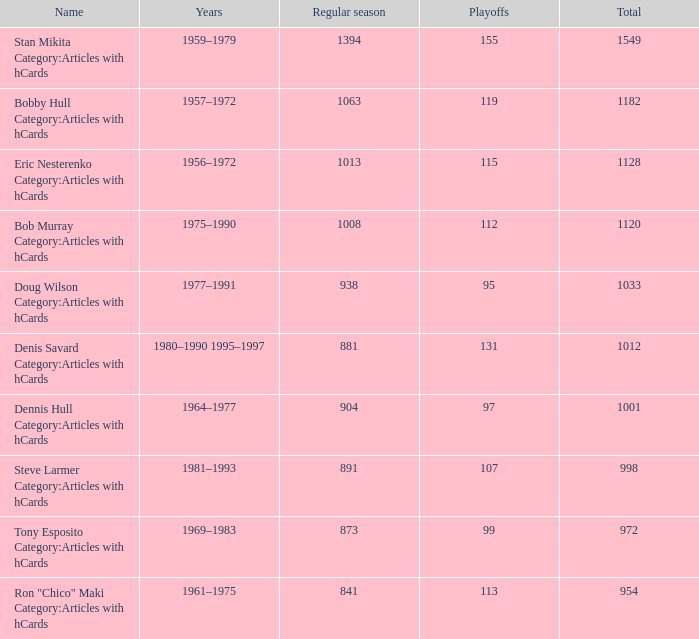What are the years when postseason games total 115? 1956–1972. 